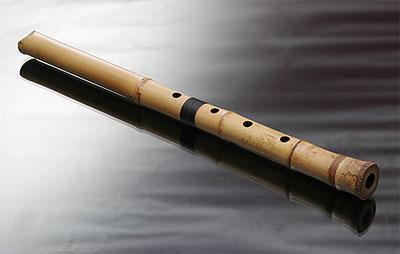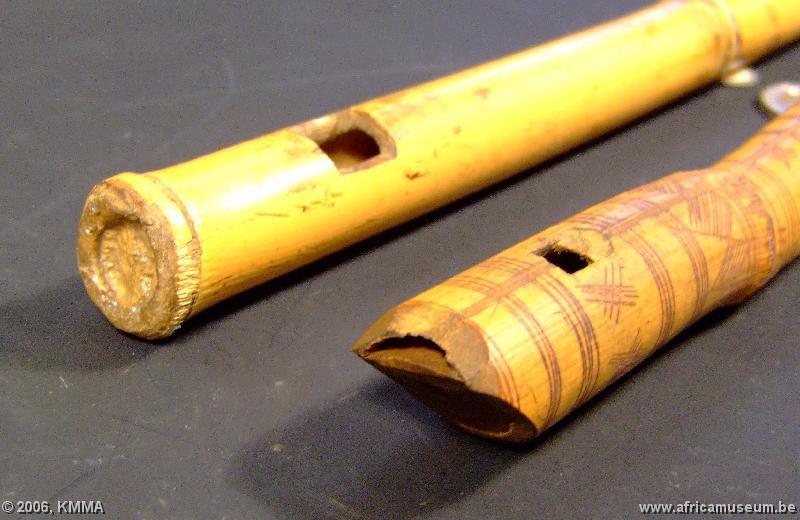The first image is the image on the left, the second image is the image on the right. Assess this claim about the two images: "Each image contains exactly one bamboo flute, and the left image shows a flute displayed diagonally and overlapping a folded band of cloth.". Correct or not? Answer yes or no. No. The first image is the image on the left, the second image is the image on the right. Analyze the images presented: Is the assertion "The left and right image contains the same number of flutes." valid? Answer yes or no. No. 